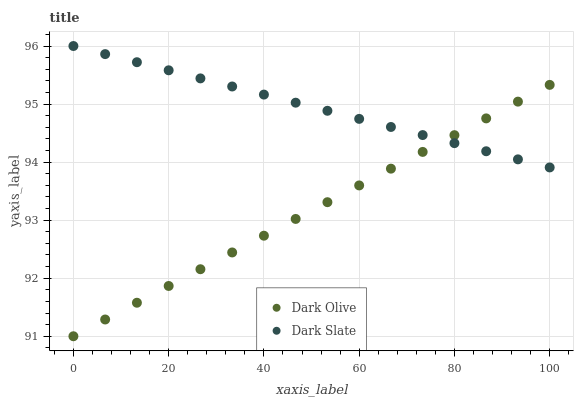Does Dark Olive have the minimum area under the curve?
Answer yes or no. Yes. Does Dark Slate have the maximum area under the curve?
Answer yes or no. Yes. Does Dark Olive have the maximum area under the curve?
Answer yes or no. No. Is Dark Slate the smoothest?
Answer yes or no. Yes. Is Dark Olive the roughest?
Answer yes or no. Yes. Is Dark Olive the smoothest?
Answer yes or no. No. Does Dark Olive have the lowest value?
Answer yes or no. Yes. Does Dark Slate have the highest value?
Answer yes or no. Yes. Does Dark Olive have the highest value?
Answer yes or no. No. Does Dark Slate intersect Dark Olive?
Answer yes or no. Yes. Is Dark Slate less than Dark Olive?
Answer yes or no. No. Is Dark Slate greater than Dark Olive?
Answer yes or no. No. 